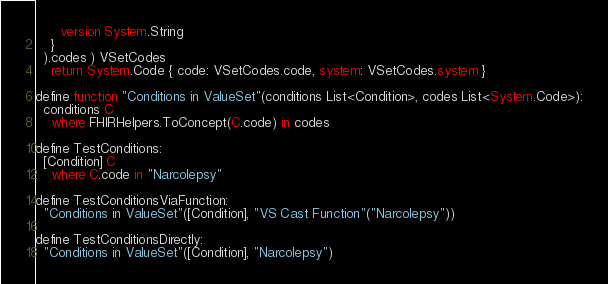Convert code to text. <code><loc_0><loc_0><loc_500><loc_500><_SQL_>      version System.String
    }
  ).codes ) VSetCodes
    return System.Code { code: VSetCodes.code, system: VSetCodes.system }

define function "Conditions in ValueSet"(conditions List<Condition>, codes List<System.Code>):
  conditions C
    where FHIRHelpers.ToConcept(C.code) in codes

define TestConditions:
  [Condition] C
    where C.code in "Narcolepsy"

define TestConditionsViaFunction:
  "Conditions in ValueSet"([Condition], "VS Cast Function"("Narcolepsy"))

define TestConditionsDirectly:
  "Conditions in ValueSet"([Condition], "Narcolepsy")
</code> 